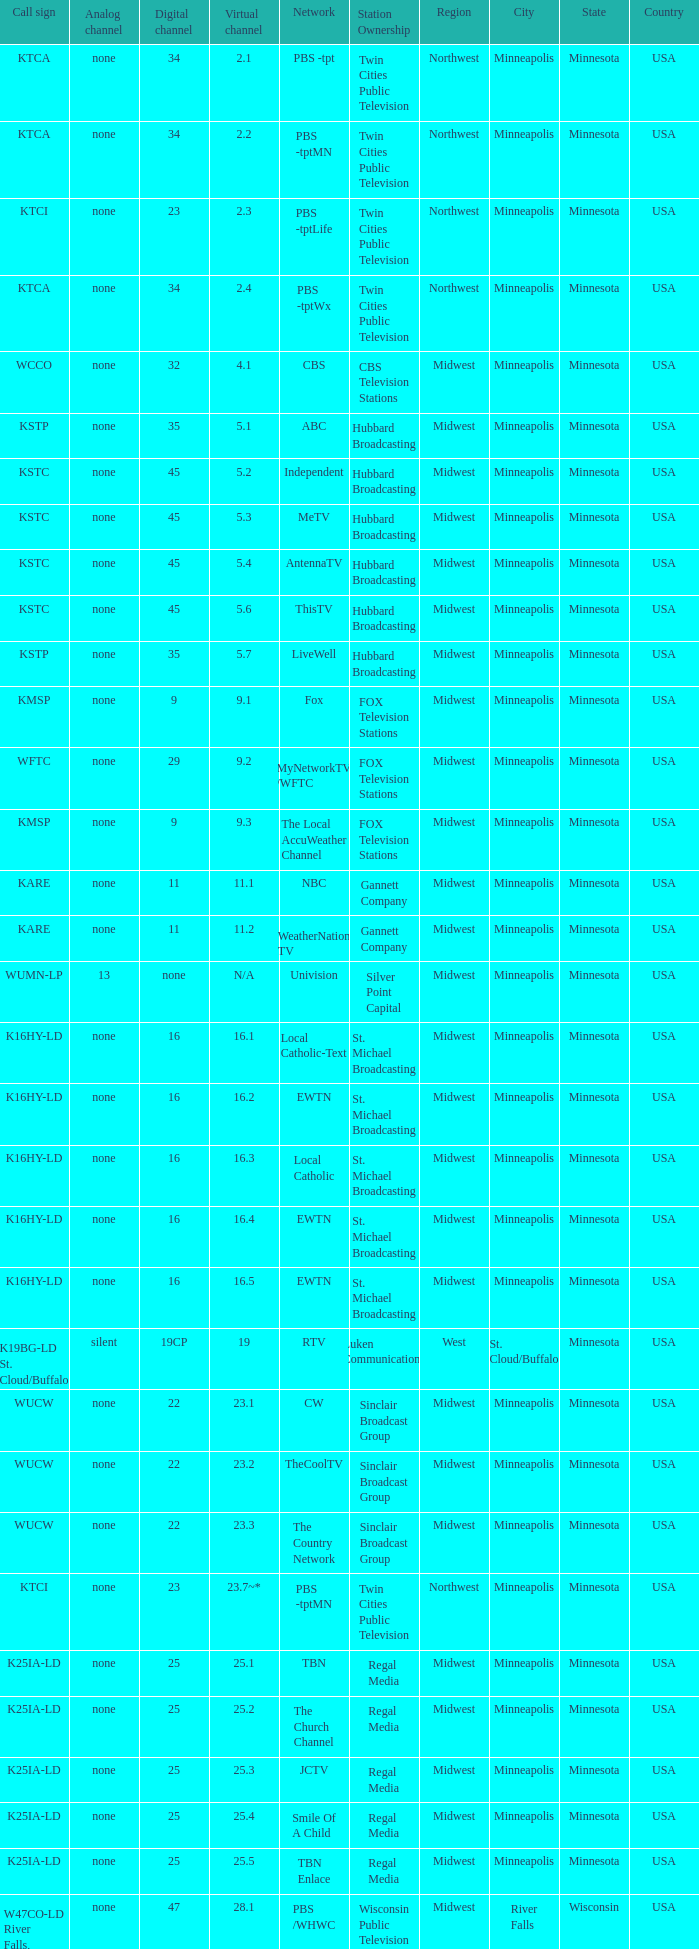5, which network is it? 3ABN Radio-Audio. 